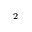<formula> <loc_0><loc_0><loc_500><loc_500>_ { 2 }</formula> 